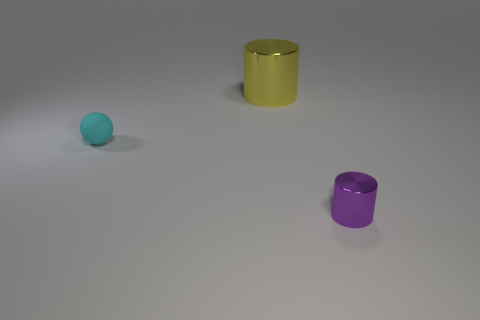Add 1 tiny yellow metal cubes. How many objects exist? 4 Subtract all purple cylinders. How many cylinders are left? 1 Subtract 1 cylinders. How many cylinders are left? 1 Subtract 0 purple balls. How many objects are left? 3 Subtract all cylinders. How many objects are left? 1 Subtract all purple balls. Subtract all purple cylinders. How many balls are left? 1 Subtract all gray cubes. How many yellow cylinders are left? 1 Subtract all purple spheres. Subtract all yellow metal objects. How many objects are left? 2 Add 1 yellow cylinders. How many yellow cylinders are left? 2 Add 2 blue rubber balls. How many blue rubber balls exist? 2 